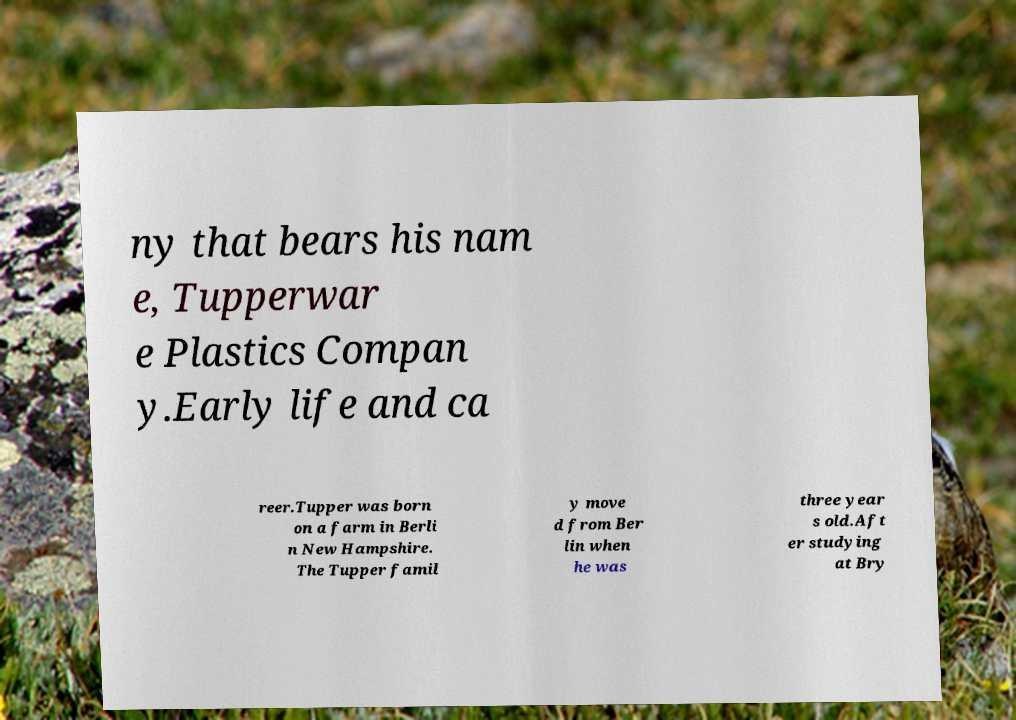Could you assist in decoding the text presented in this image and type it out clearly? ny that bears his nam e, Tupperwar e Plastics Compan y.Early life and ca reer.Tupper was born on a farm in Berli n New Hampshire. The Tupper famil y move d from Ber lin when he was three year s old.Aft er studying at Bry 